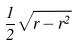<formula> <loc_0><loc_0><loc_500><loc_500>\frac { 1 } { 2 } \sqrt { r - r ^ { 2 } }</formula> 